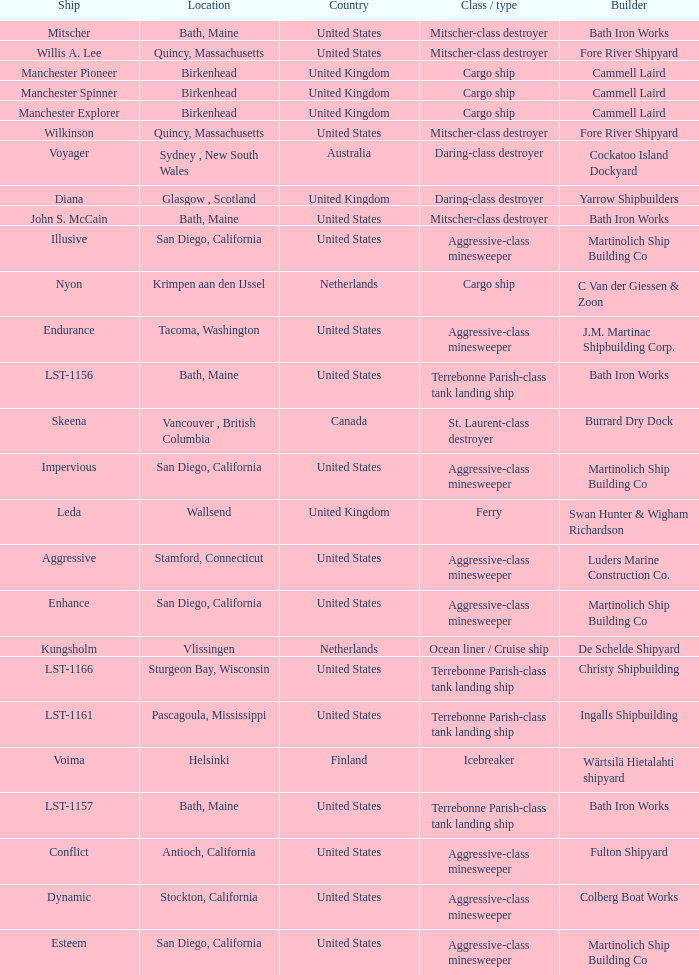What is the Cargo Ship located at Birkenhead? Manchester Pioneer, Manchester Spinner, Manchester Explorer. Can you give me this table as a dict? {'header': ['Ship', 'Location', 'Country', 'Class / type', 'Builder'], 'rows': [['Mitscher', 'Bath, Maine', 'United States', 'Mitscher-class destroyer', 'Bath Iron Works'], ['Willis A. Lee', 'Quincy, Massachusetts', 'United States', 'Mitscher-class destroyer', 'Fore River Shipyard'], ['Manchester Pioneer', 'Birkenhead', 'United Kingdom', 'Cargo ship', 'Cammell Laird'], ['Manchester Spinner', 'Birkenhead', 'United Kingdom', 'Cargo ship', 'Cammell Laird'], ['Manchester Explorer', 'Birkenhead', 'United Kingdom', 'Cargo ship', 'Cammell Laird'], ['Wilkinson', 'Quincy, Massachusetts', 'United States', 'Mitscher-class destroyer', 'Fore River Shipyard'], ['Voyager', 'Sydney , New South Wales', 'Australia', 'Daring-class destroyer', 'Cockatoo Island Dockyard'], ['Diana', 'Glasgow , Scotland', 'United Kingdom', 'Daring-class destroyer', 'Yarrow Shipbuilders'], ['John S. McCain', 'Bath, Maine', 'United States', 'Mitscher-class destroyer', 'Bath Iron Works'], ['Illusive', 'San Diego, California', 'United States', 'Aggressive-class minesweeper', 'Martinolich Ship Building Co'], ['Nyon', 'Krimpen aan den IJssel', 'Netherlands', 'Cargo ship', 'C Van der Giessen & Zoon'], ['Endurance', 'Tacoma, Washington', 'United States', 'Aggressive-class minesweeper', 'J.M. Martinac Shipbuilding Corp.'], ['LST-1156', 'Bath, Maine', 'United States', 'Terrebonne Parish-class tank landing ship', 'Bath Iron Works'], ['Skeena', 'Vancouver , British Columbia', 'Canada', 'St. Laurent-class destroyer', 'Burrard Dry Dock'], ['Impervious', 'San Diego, California', 'United States', 'Aggressive-class minesweeper', 'Martinolich Ship Building Co'], ['Leda', 'Wallsend', 'United Kingdom', 'Ferry', 'Swan Hunter & Wigham Richardson'], ['Aggressive', 'Stamford, Connecticut', 'United States', 'Aggressive-class minesweeper', 'Luders Marine Construction Co.'], ['Enhance', 'San Diego, California', 'United States', 'Aggressive-class minesweeper', 'Martinolich Ship Building Co'], ['Kungsholm', 'Vlissingen', 'Netherlands', 'Ocean liner / Cruise ship', 'De Schelde Shipyard'], ['LST-1166', 'Sturgeon Bay, Wisconsin', 'United States', 'Terrebonne Parish-class tank landing ship', 'Christy Shipbuilding'], ['LST-1161', 'Pascagoula, Mississippi', 'United States', 'Terrebonne Parish-class tank landing ship', 'Ingalls Shipbuilding'], ['Voima', 'Helsinki', 'Finland', 'Icebreaker', 'Wärtsilä Hietalahti shipyard'], ['LST-1157', 'Bath, Maine', 'United States', 'Terrebonne Parish-class tank landing ship', 'Bath Iron Works'], ['Conflict', 'Antioch, California', 'United States', 'Aggressive-class minesweeper', 'Fulton Shipyard'], ['Dynamic', 'Stockton, California', 'United States', 'Aggressive-class minesweeper', 'Colberg Boat Works'], ['Esteem', 'San Diego, California', 'United States', 'Aggressive-class minesweeper', 'Martinolich Ship Building Co']]} 